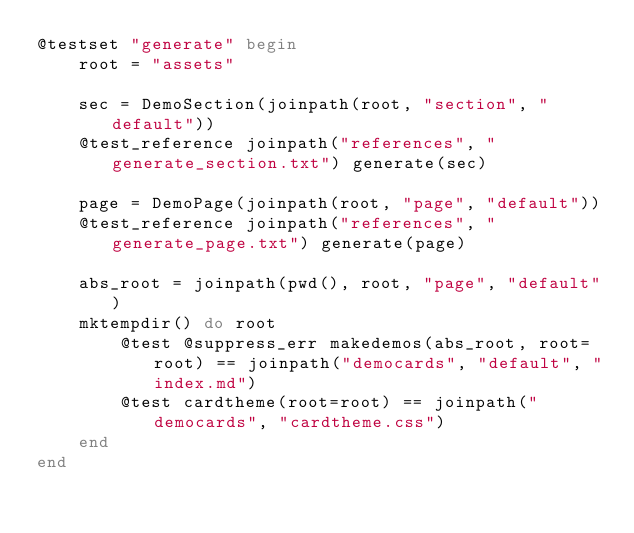Convert code to text. <code><loc_0><loc_0><loc_500><loc_500><_Julia_>@testset "generate" begin
    root = "assets"

    sec = DemoSection(joinpath(root, "section", "default"))
    @test_reference joinpath("references", "generate_section.txt") generate(sec)

    page = DemoPage(joinpath(root, "page", "default"))
    @test_reference joinpath("references", "generate_page.txt") generate(page)

    abs_root = joinpath(pwd(), root, "page", "default")
    mktempdir() do root
        @test @suppress_err makedemos(abs_root, root=root) == joinpath("democards", "default", "index.md")
        @test cardtheme(root=root) == joinpath("democards", "cardtheme.css")
    end
end
</code> 